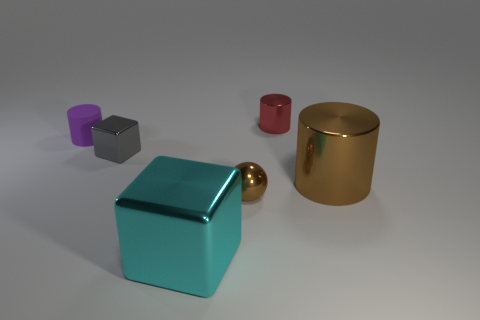The other cylinder that is the same material as the big brown cylinder is what size?
Make the answer very short. Small. How many small things are on the right side of the tiny cylinder right of the purple cylinder?
Your response must be concise. 0. Does the large thing that is right of the big cube have the same material as the small red thing?
Your answer should be very brief. Yes. Is there anything else that is the same material as the purple object?
Your response must be concise. No. There is a brown thing that is to the right of the small metallic thing that is behind the purple matte object; how big is it?
Give a very brief answer. Large. There is a brown metallic thing that is in front of the brown thing that is to the right of the tiny object behind the purple object; what is its size?
Give a very brief answer. Small. Do the metallic object behind the small purple matte cylinder and the brown shiny object that is to the right of the tiny metal sphere have the same shape?
Ensure brevity in your answer.  Yes. How many other things are there of the same color as the rubber thing?
Your response must be concise. 0. There is a purple cylinder on the left side of the brown ball; is it the same size as the brown cylinder?
Offer a very short reply. No. Does the cylinder that is behind the tiny purple rubber thing have the same material as the cylinder that is on the left side of the tiny brown shiny thing?
Your answer should be compact. No. 